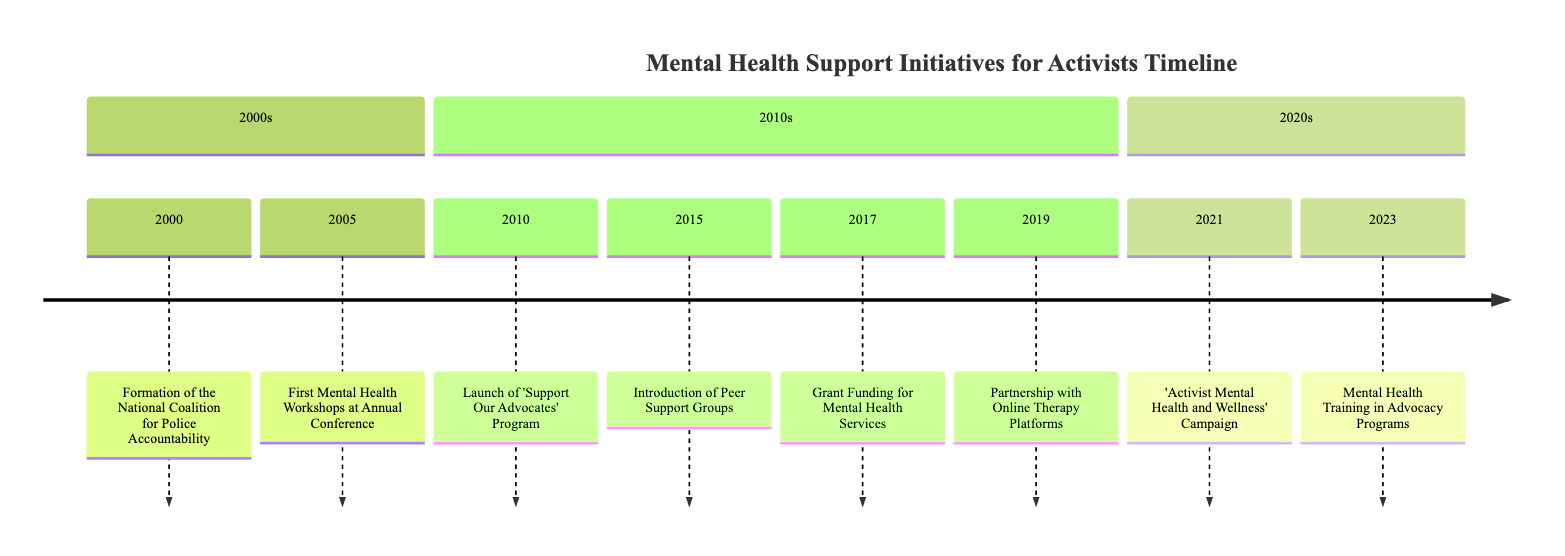What year did the 'Support Our Advocates' Program launch? The diagram indicates the launch year for the 'Support Our Advocates' Program being 2010.
Answer: 2010 What event occurred in 2005? Referring to the diagram, the event that occurred in 2005 was the First Mental Health Workshops at the Annual Police Accountability Conference.
Answer: First Mental Health Workshops at Annual Conference How many initiatives were introduced in the 2010s? By counting the events listed in the 2010s section of the diagram, there are 5 initiatives introduced during this decade.
Answer: 5 Which organization launched the 'Activist Mental Health and Wellness' Campaign? The diagram specifies that Mental Health America launched the 'Activist Mental Health and Wellness' Campaign in 2021.
Answer: Mental Health America What is a key feature of the 2023 event in the timeline? The event in 2023 highlights the integration of mental health training in advocacy programs, indicating a focus on improving training support for activists.
Answer: Mental Health Training in Advocacy Programs What kind of support did the peer support groups introduced in 2015 focus on? The diagram describes that peer support groups were established to focus on shared experiences and emotional support for activists.
Answer: Shared experiences and emotional support Which groups or organizations were involved in the partnership with online therapy platforms in 2019? The diagram does not specify individual organizations involved during this partnership; however, it indicates that organizations collaborated with platforms to enhance access to mental health resources.
Answer: Organizations with online therapy platforms What significant funding initiative began in 2017? According to the timeline, grant funding for mental health services was initiated in 2017.
Answer: Grant Funding for Mental Health Services 